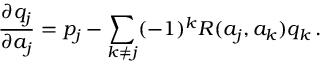<formula> <loc_0><loc_0><loc_500><loc_500>{ \frac { \partial q _ { j } } { \partial a _ { j } } } = p _ { j } - \sum _ { k \neq j } ( - 1 ) ^ { k } R ( a _ { j } , a _ { k } ) q _ { k } \, .</formula> 